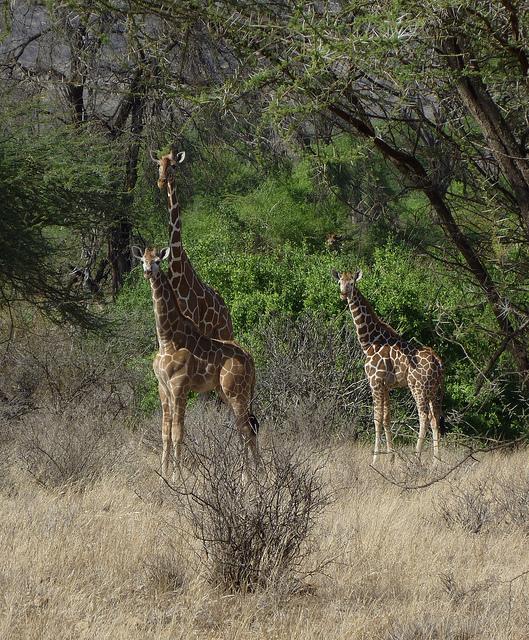What style of grass are the giraffes standing in?
Give a very brief answer. Weeds. How tall do you think this giraffe is?
Write a very short answer. 12 feet. Does this look like a zoo?
Concise answer only. No. What animals are these?
Short answer required. Giraffe. How many giraffes are there?
Write a very short answer. 3. 